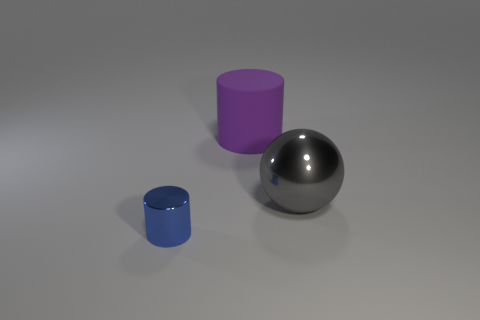What shape is the gray object that is the same size as the purple rubber cylinder?
Ensure brevity in your answer.  Sphere. There is a big thing that is behind the metallic thing that is behind the thing to the left of the purple thing; what is it made of?
Give a very brief answer. Rubber. Do the shiny thing that is left of the rubber cylinder and the large object that is left of the large gray metallic object have the same shape?
Give a very brief answer. Yes. What number of other things are there of the same material as the purple object
Your response must be concise. 0. Do the cylinder in front of the metal ball and the large object that is in front of the purple object have the same material?
Provide a short and direct response. Yes. What is the shape of the other big thing that is the same material as the blue thing?
Your answer should be very brief. Sphere. Are there any other things that have the same color as the matte object?
Keep it short and to the point. No. How many big yellow metallic blocks are there?
Offer a terse response. 0. What is the shape of the thing that is both in front of the rubber object and on the left side of the big gray metallic sphere?
Provide a short and direct response. Cylinder. The big metal thing right of the big thing that is to the left of the metallic thing that is on the right side of the large purple cylinder is what shape?
Keep it short and to the point. Sphere. 